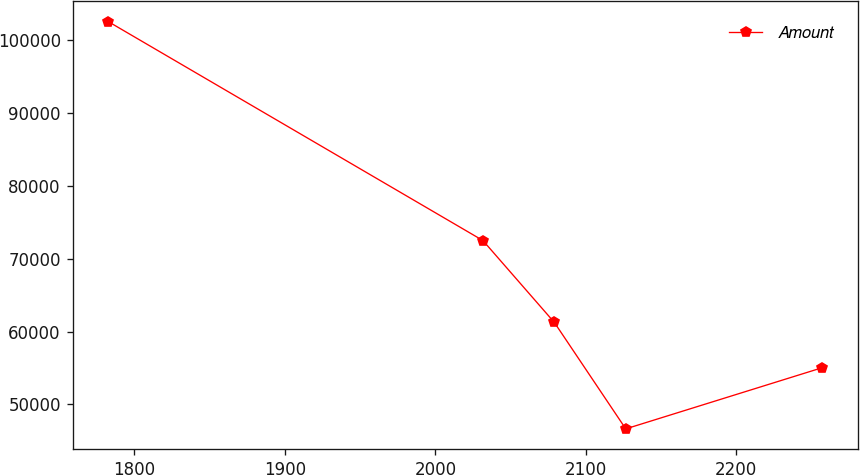<chart> <loc_0><loc_0><loc_500><loc_500><line_chart><ecel><fcel>Amount<nl><fcel>1782.61<fcel>102572<nl><fcel>2031.64<fcel>72505<nl><fcel>2079.09<fcel>61262.3<nl><fcel>2126.54<fcel>46653.2<nl><fcel>2257.15<fcel>55053.5<nl></chart> 